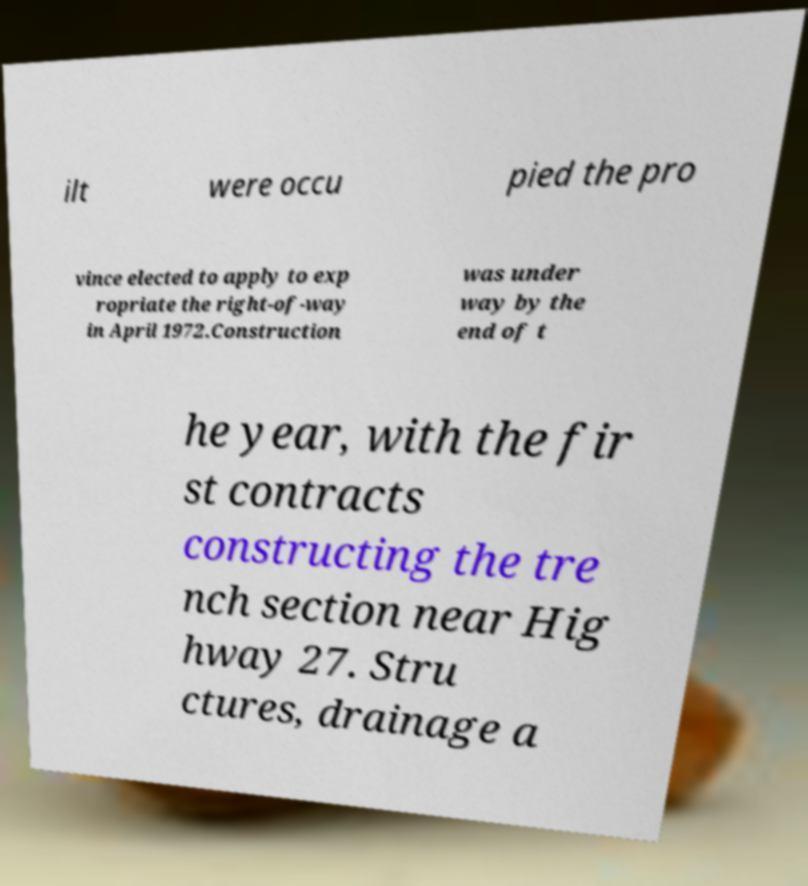Could you assist in decoding the text presented in this image and type it out clearly? ilt were occu pied the pro vince elected to apply to exp ropriate the right-of-way in April 1972.Construction was under way by the end of t he year, with the fir st contracts constructing the tre nch section near Hig hway 27. Stru ctures, drainage a 